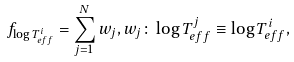Convert formula to latex. <formula><loc_0><loc_0><loc_500><loc_500>f _ { \log T _ { e f f } ^ { i } } = \sum _ { j = 1 } ^ { N } w _ { j } , w _ { j } \colon \log T _ { e f f } ^ { j } \equiv \log T _ { e f f } ^ { i } ,</formula> 